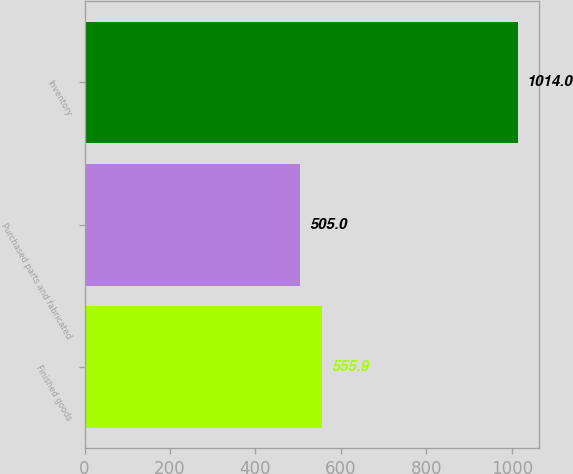Convert chart. <chart><loc_0><loc_0><loc_500><loc_500><bar_chart><fcel>Finished goods<fcel>Purchased parts and fabricated<fcel>Inventory<nl><fcel>555.9<fcel>505<fcel>1014<nl></chart> 